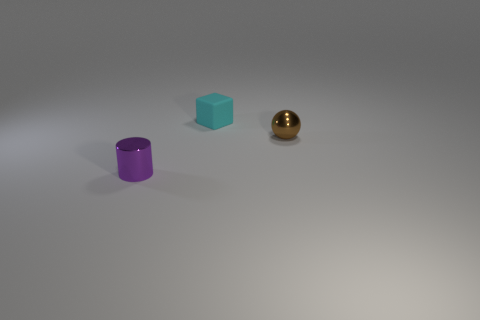There is a tiny brown metal object; what shape is it?
Offer a very short reply. Sphere. There is a metal thing that is behind the tiny purple thing; is its shape the same as the tiny cyan thing?
Offer a terse response. No. Are there more small things right of the cyan rubber thing than tiny purple objects left of the tiny purple cylinder?
Keep it short and to the point. Yes. What number of other objects are there of the same size as the cyan block?
Your answer should be very brief. 2. What number of shiny objects are big red cylinders or small cylinders?
Make the answer very short. 1. Is there a small cyan matte object?
Provide a succinct answer. Yes. What number of big objects are cyan things or shiny cylinders?
Give a very brief answer. 0. What is the color of the tiny shiny cylinder?
Provide a short and direct response. Purple. There is a metallic thing that is right of the object left of the cyan thing; what is its shape?
Offer a very short reply. Sphere. Are there any purple cylinders that have the same material as the cyan block?
Provide a succinct answer. No. 